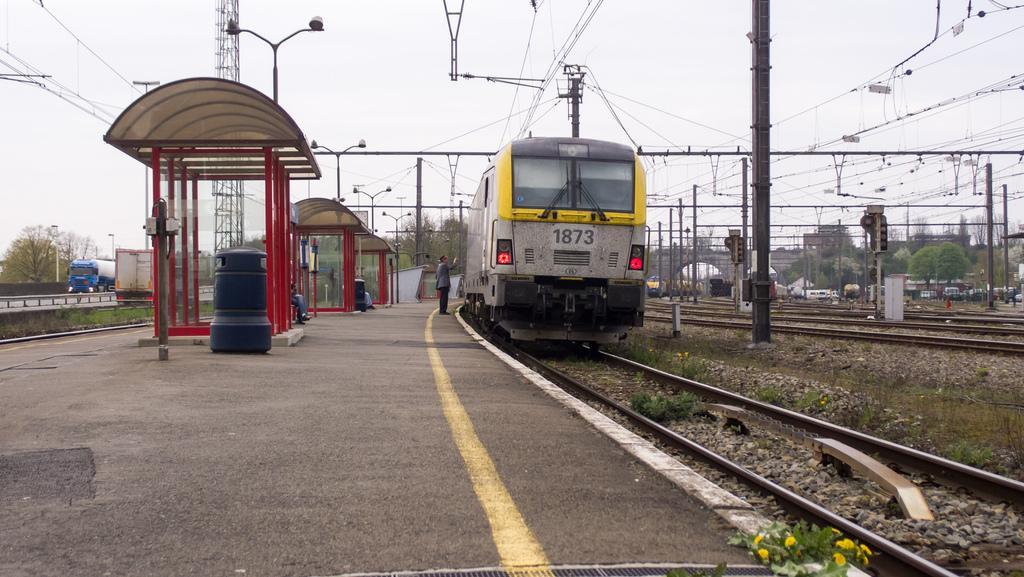How would you summarize this image in a sentence or two? In the image we can see trains on the train tracks. We can see grass, road, electric pole and electric wires. We can even see person standing and wearing clothes. Here we can see tower, trees and there are vehicles. Here we can see an object, station booth and the sky. 